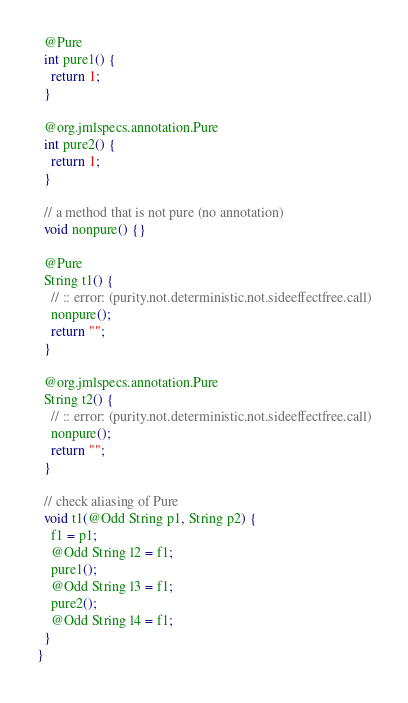Convert code to text. <code><loc_0><loc_0><loc_500><loc_500><_Java_>
  @Pure
  int pure1() {
    return 1;
  }

  @org.jmlspecs.annotation.Pure
  int pure2() {
    return 1;
  }

  // a method that is not pure (no annotation)
  void nonpure() {}

  @Pure
  String t1() {
    // :: error: (purity.not.deterministic.not.sideeffectfree.call)
    nonpure();
    return "";
  }

  @org.jmlspecs.annotation.Pure
  String t2() {
    // :: error: (purity.not.deterministic.not.sideeffectfree.call)
    nonpure();
    return "";
  }

  // check aliasing of Pure
  void t1(@Odd String p1, String p2) {
    f1 = p1;
    @Odd String l2 = f1;
    pure1();
    @Odd String l3 = f1;
    pure2();
    @Odd String l4 = f1;
  }
}
</code> 